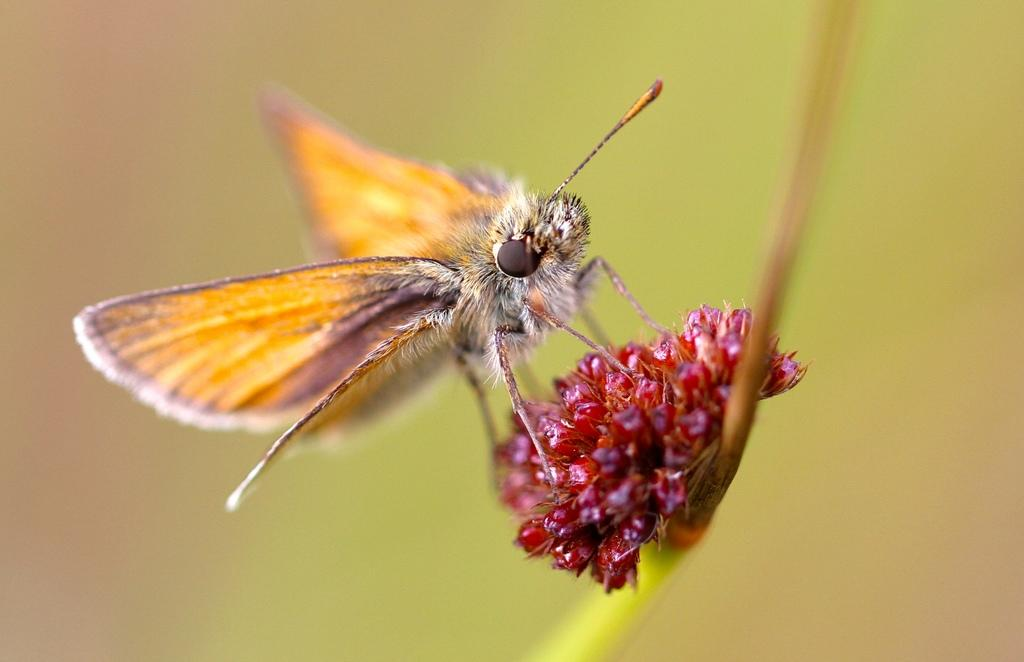What is present on the flower in the image? There is an insect on the flower in the image. Can you describe the insect's location in relation to the flower? The insect is on the flower. What can be observed about the background of the image? The background of the image is blurred. How many dogs are visible in the image? There are no dogs present in the image. What type of cabbage is being used as a hat in the image? There is no cabbage or hat present in the image. 